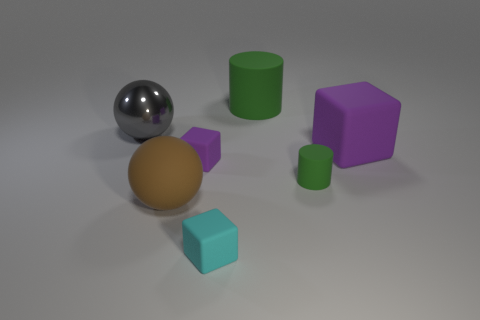What is the size of the other rubber cube that is the same color as the big block?
Provide a short and direct response. Small. Are there more small cyan matte cubes behind the large gray ball than tiny cyan rubber cubes?
Ensure brevity in your answer.  No. What number of balls are tiny cyan objects or large things?
Your answer should be compact. 2. There is a small rubber object that is on the right side of the tiny purple block and behind the rubber sphere; what shape is it?
Keep it short and to the point. Cylinder. Are there an equal number of large gray spheres in front of the cyan rubber cube and big cylinders that are in front of the tiny purple matte object?
Offer a very short reply. Yes. What number of things are either metallic things or small purple things?
Give a very brief answer. 2. The block that is the same size as the cyan thing is what color?
Keep it short and to the point. Purple. How many objects are either green cylinders that are in front of the gray metallic object or big rubber objects right of the cyan object?
Your answer should be very brief. 3. Are there an equal number of tiny cyan rubber objects behind the tiny purple object and big brown balls?
Provide a succinct answer. No. Do the sphere that is on the right side of the gray metallic object and the rubber cube that is right of the small cyan rubber thing have the same size?
Offer a very short reply. Yes. 